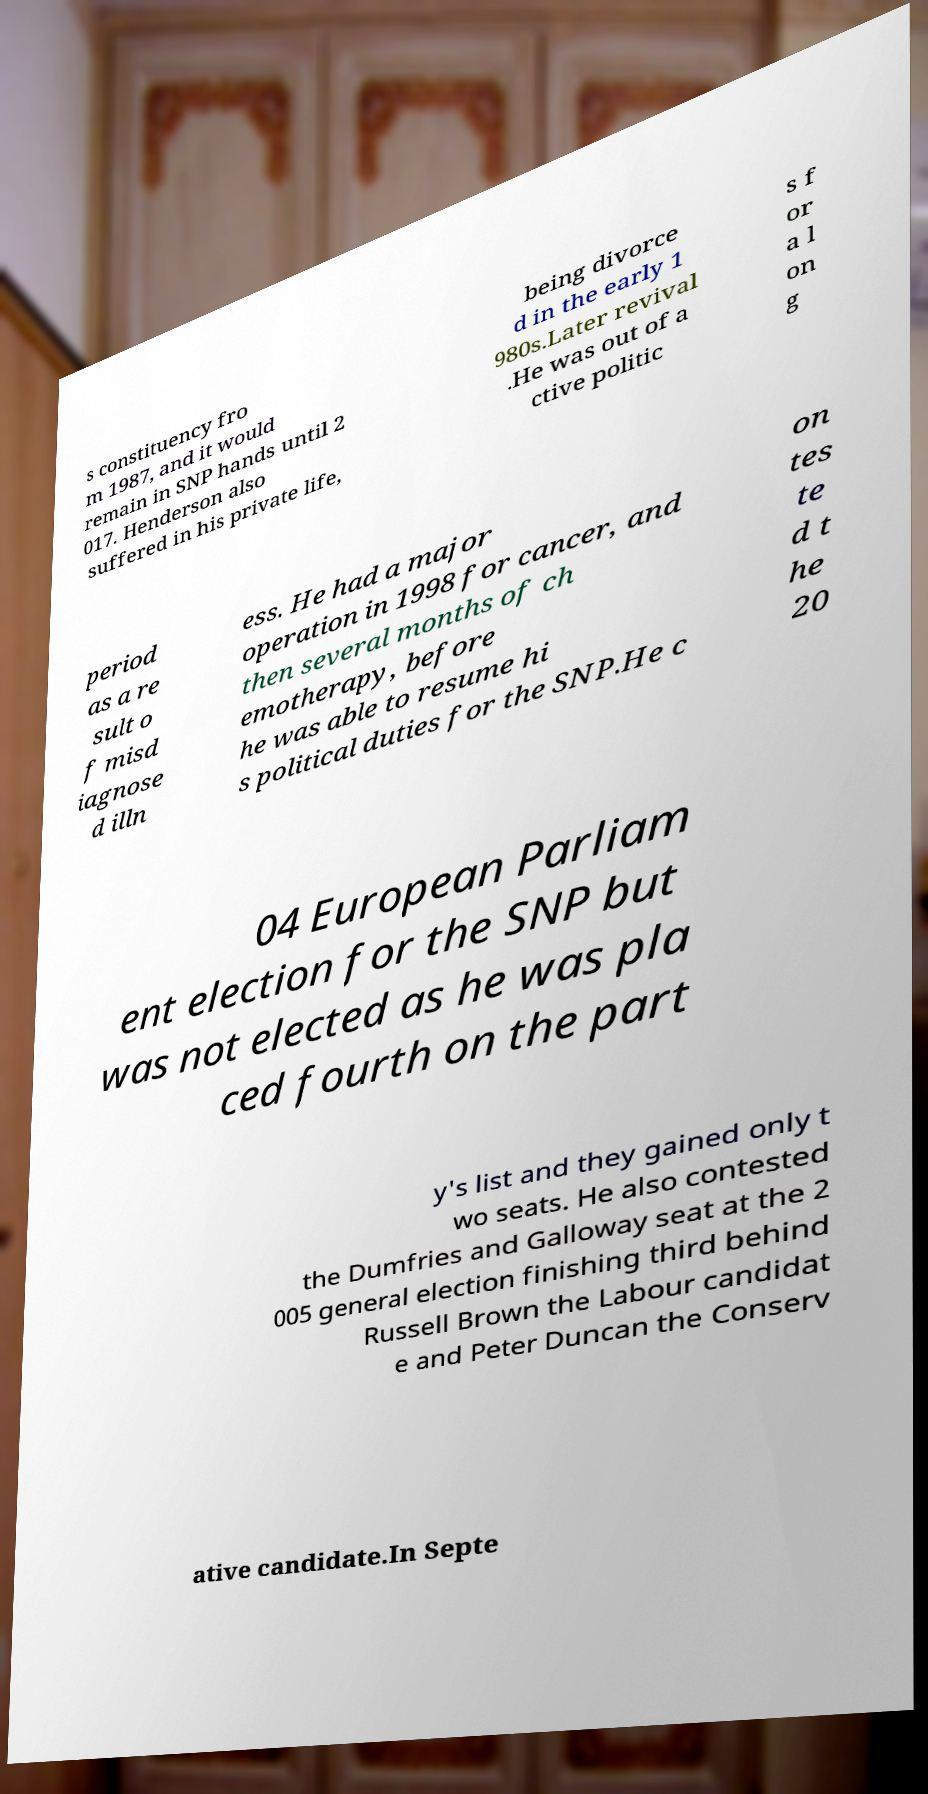Could you assist in decoding the text presented in this image and type it out clearly? s constituency fro m 1987, and it would remain in SNP hands until 2 017. Henderson also suffered in his private life, being divorce d in the early 1 980s.Later revival .He was out of a ctive politic s f or a l on g period as a re sult o f misd iagnose d illn ess. He had a major operation in 1998 for cancer, and then several months of ch emotherapy, before he was able to resume hi s political duties for the SNP.He c on tes te d t he 20 04 European Parliam ent election for the SNP but was not elected as he was pla ced fourth on the part y's list and they gained only t wo seats. He also contested the Dumfries and Galloway seat at the 2 005 general election finishing third behind Russell Brown the Labour candidat e and Peter Duncan the Conserv ative candidate.In Septe 